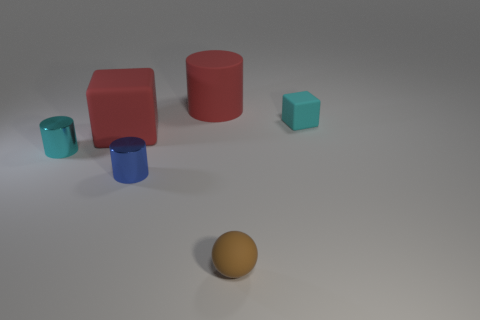Add 3 green matte spheres. How many objects exist? 9 Subtract all blocks. How many objects are left? 4 Add 3 cyan matte blocks. How many cyan matte blocks are left? 4 Add 4 big green metallic cylinders. How many big green metallic cylinders exist? 4 Subtract 0 purple cylinders. How many objects are left? 6 Subtract all cyan matte blocks. Subtract all cyan matte blocks. How many objects are left? 4 